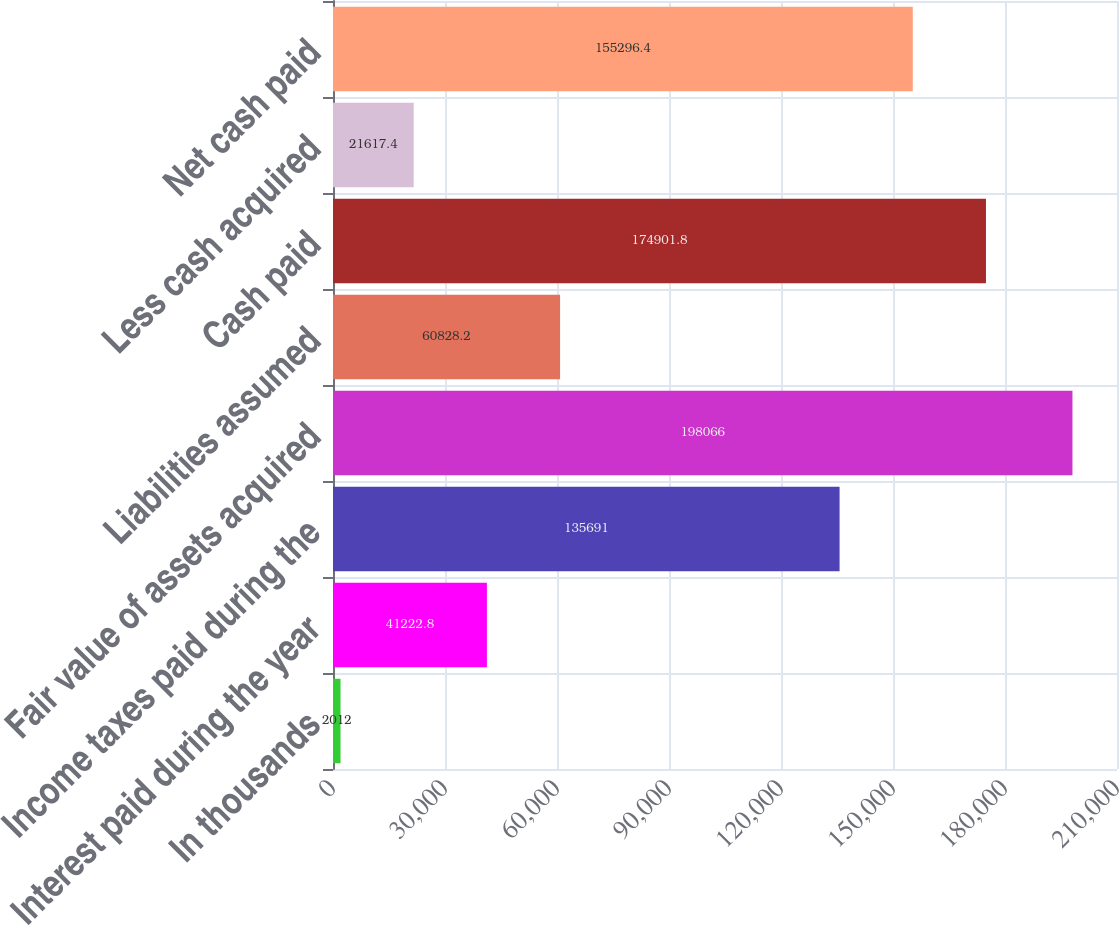Convert chart to OTSL. <chart><loc_0><loc_0><loc_500><loc_500><bar_chart><fcel>In thousands<fcel>Interest paid during the year<fcel>Income taxes paid during the<fcel>Fair value of assets acquired<fcel>Liabilities assumed<fcel>Cash paid<fcel>Less cash acquired<fcel>Net cash paid<nl><fcel>2012<fcel>41222.8<fcel>135691<fcel>198066<fcel>60828.2<fcel>174902<fcel>21617.4<fcel>155296<nl></chart> 